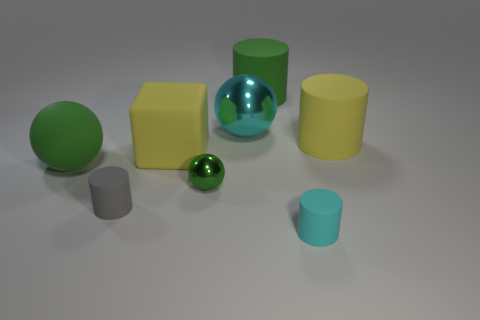Add 1 purple matte cylinders. How many objects exist? 9 Subtract all balls. How many objects are left? 5 Subtract 0 brown cubes. How many objects are left? 8 Subtract all green things. Subtract all tiny cyan matte objects. How many objects are left? 4 Add 4 cyan spheres. How many cyan spheres are left? 5 Add 6 purple objects. How many purple objects exist? 6 